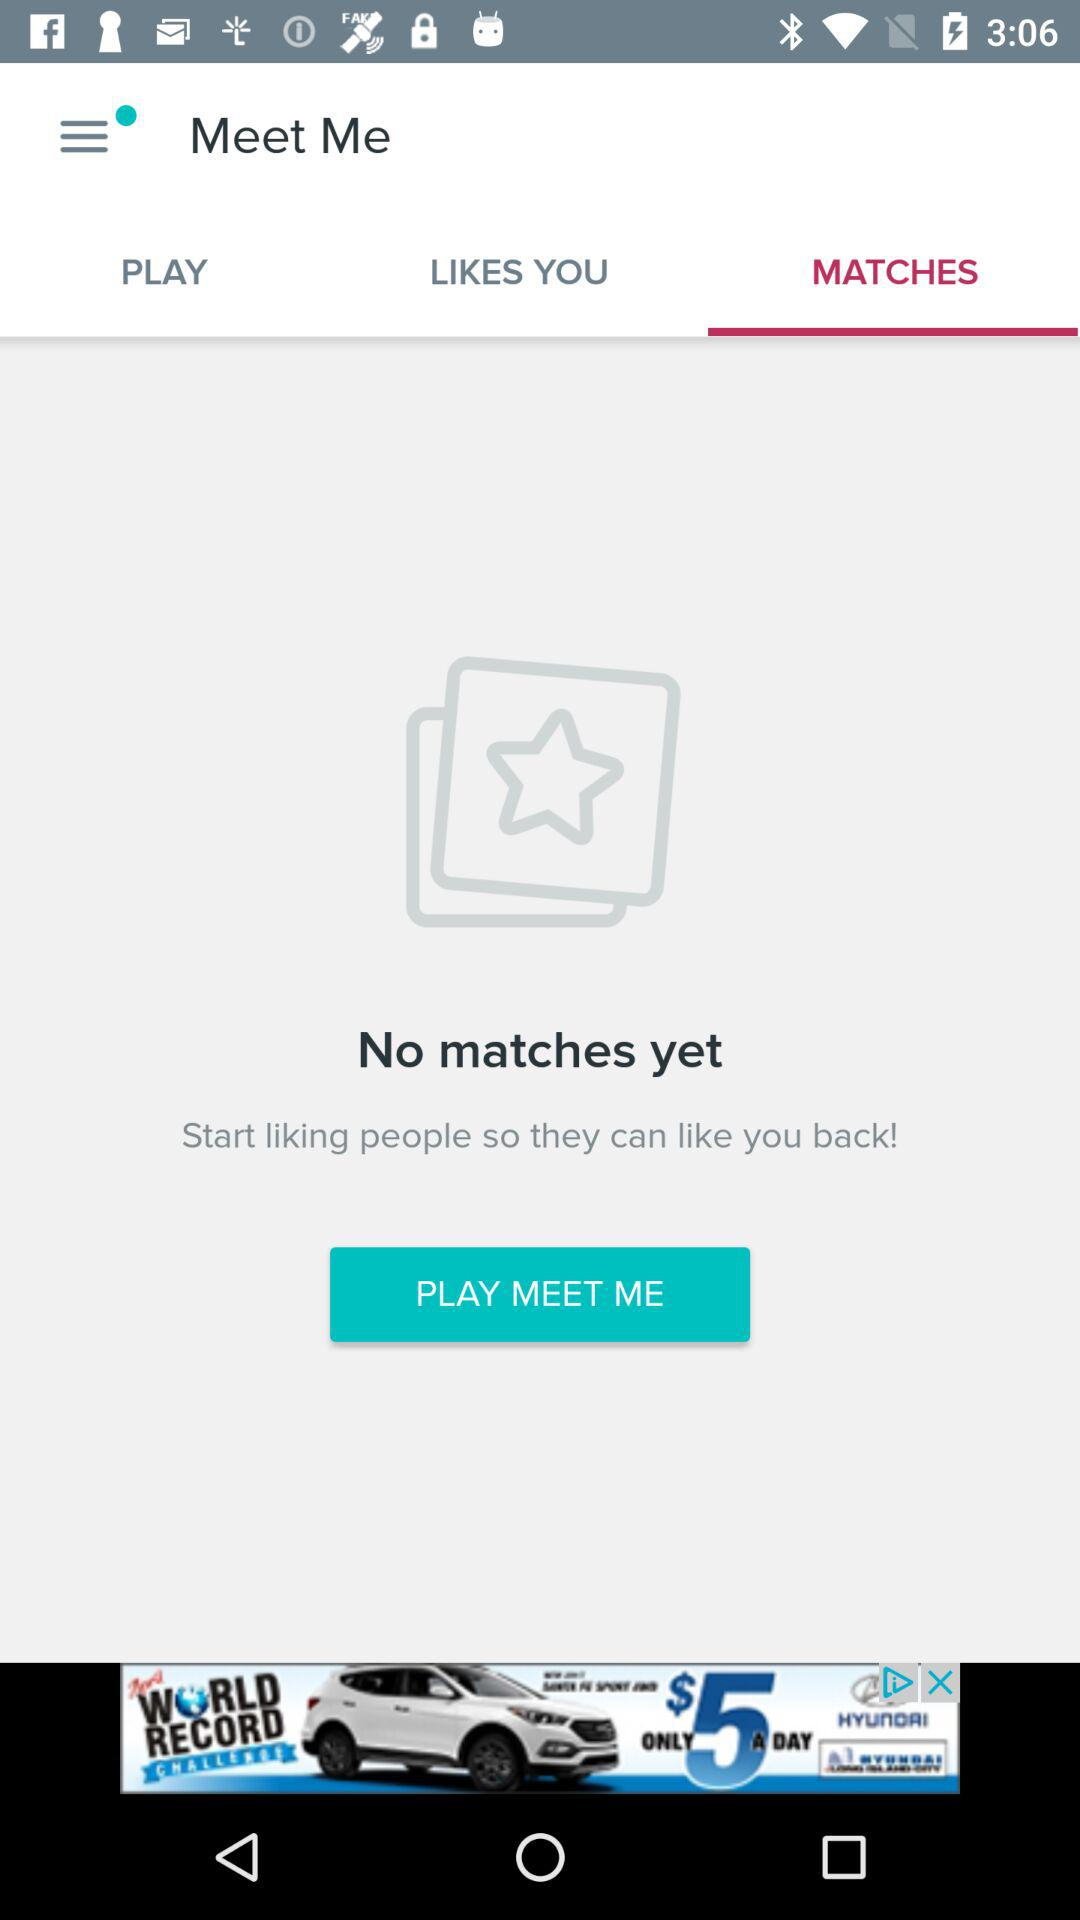What is the application name? The application name is "Meet Me". 